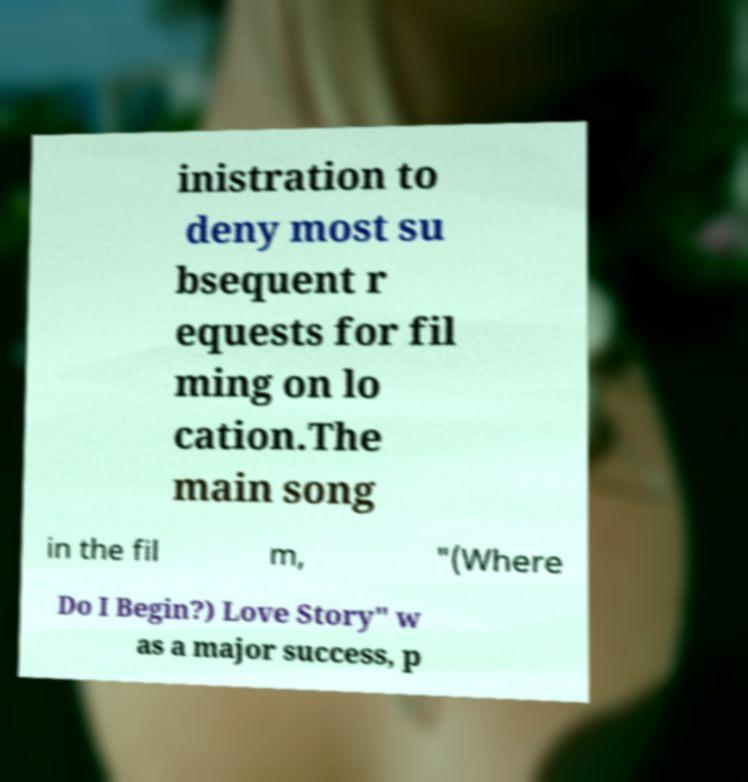I need the written content from this picture converted into text. Can you do that? inistration to deny most su bsequent r equests for fil ming on lo cation.The main song in the fil m, "(Where Do I Begin?) Love Story" w as a major success, p 